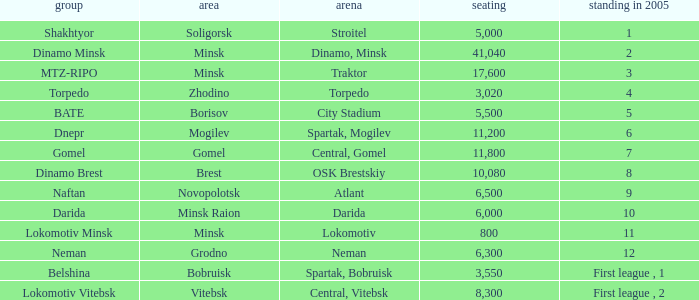Can you tell me the highest Capacity that has the Team of torpedo? 3020.0. 